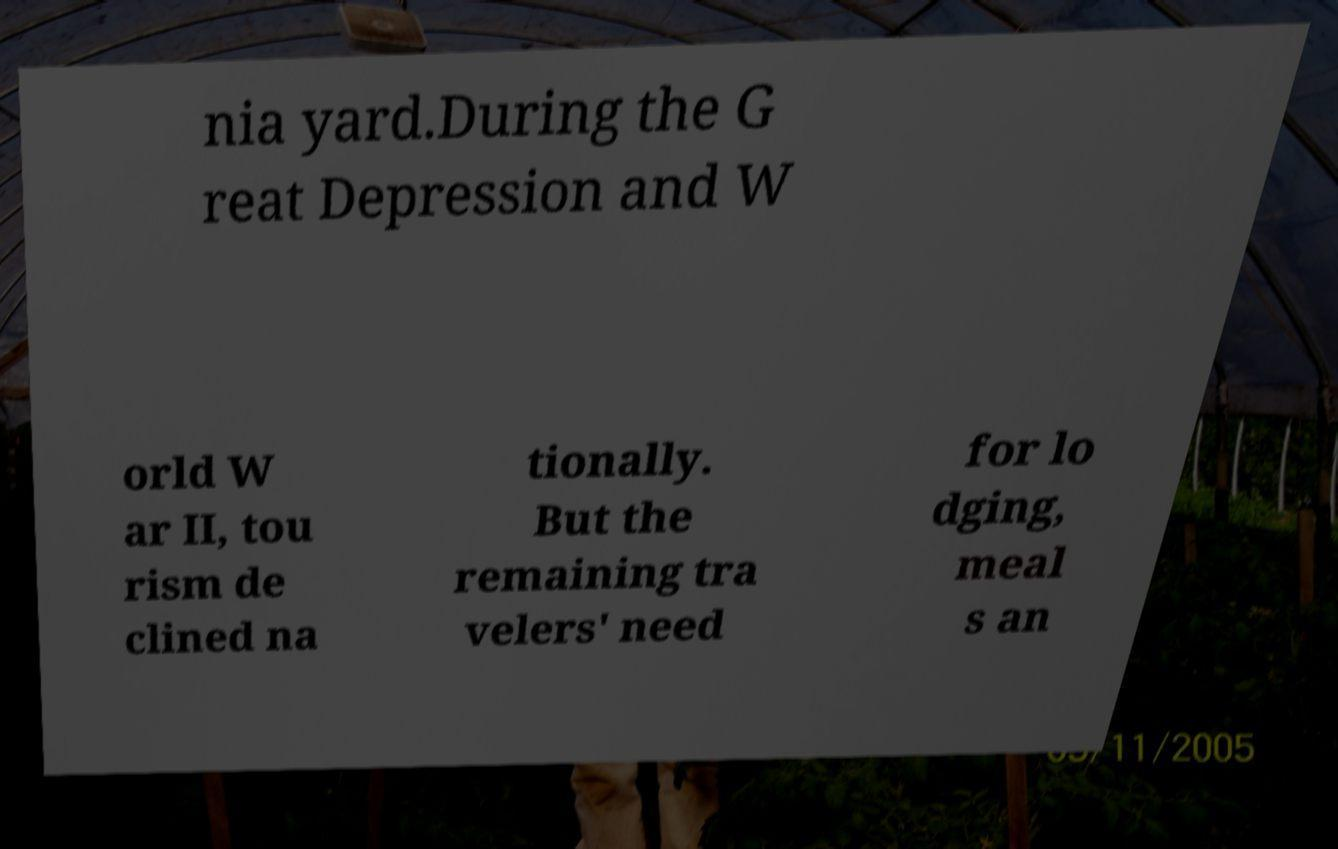Could you assist in decoding the text presented in this image and type it out clearly? nia yard.During the G reat Depression and W orld W ar II, tou rism de clined na tionally. But the remaining tra velers' need for lo dging, meal s an 